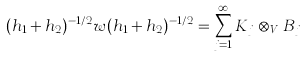<formula> <loc_0><loc_0><loc_500><loc_500>( h _ { 1 } + h _ { 2 } ) ^ { - 1 / 2 } w ( h _ { 1 } + h _ { 2 } ) ^ { - 1 / 2 } = \sum _ { j = 1 } ^ { \infty } K _ { j } \otimes _ { V } B _ { j }</formula> 